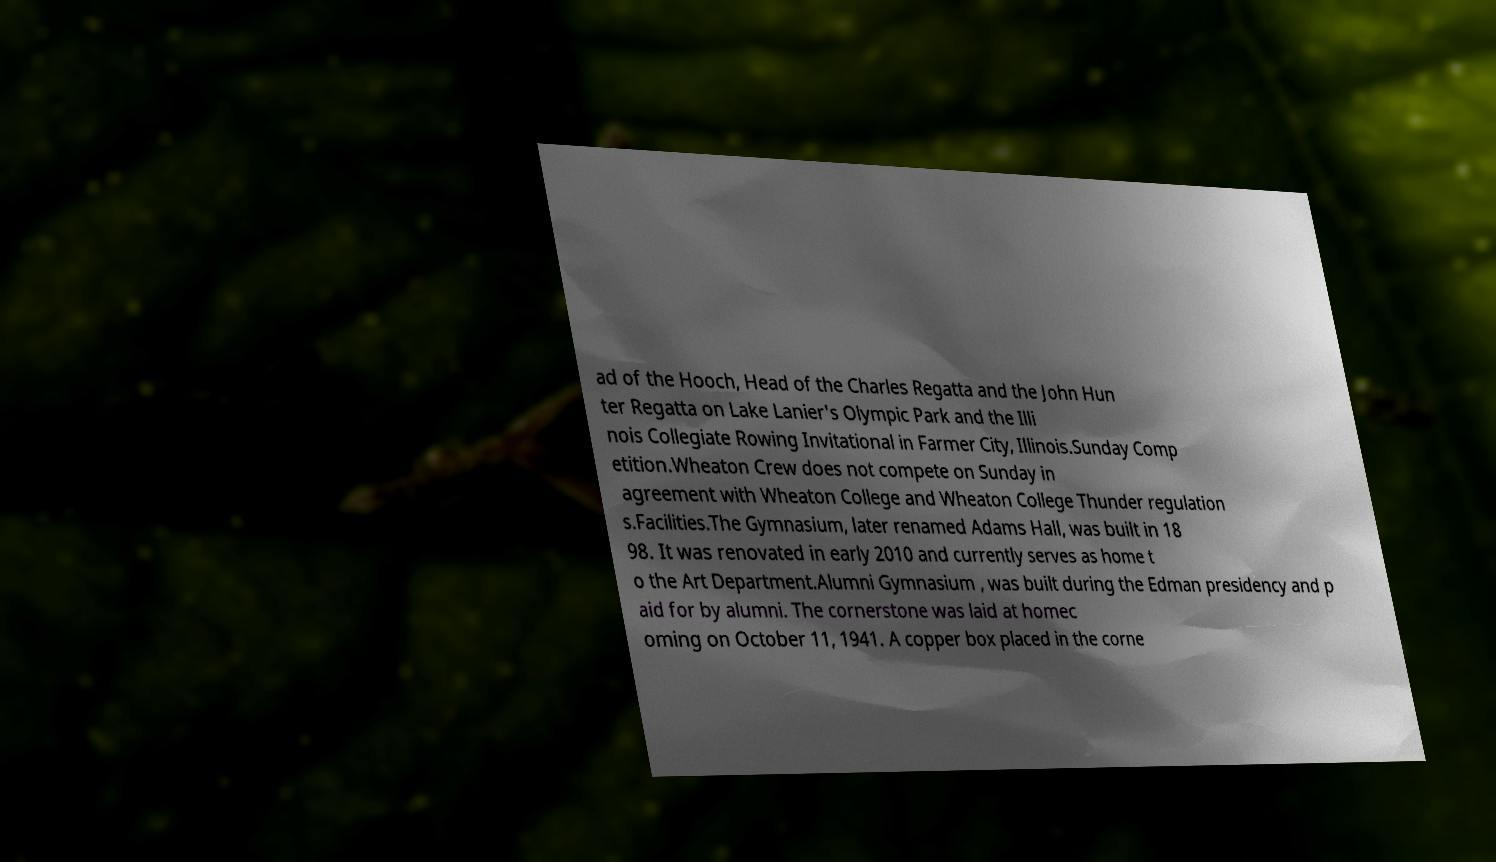There's text embedded in this image that I need extracted. Can you transcribe it verbatim? ad of the Hooch, Head of the Charles Regatta and the John Hun ter Regatta on Lake Lanier's Olympic Park and the Illi nois Collegiate Rowing Invitational in Farmer City, Illinois.Sunday Comp etition.Wheaton Crew does not compete on Sunday in agreement with Wheaton College and Wheaton College Thunder regulation s.Facilities.The Gymnasium, later renamed Adams Hall, was built in 18 98. It was renovated in early 2010 and currently serves as home t o the Art Department.Alumni Gymnasium , was built during the Edman presidency and p aid for by alumni. The cornerstone was laid at homec oming on October 11, 1941. A copper box placed in the corne 